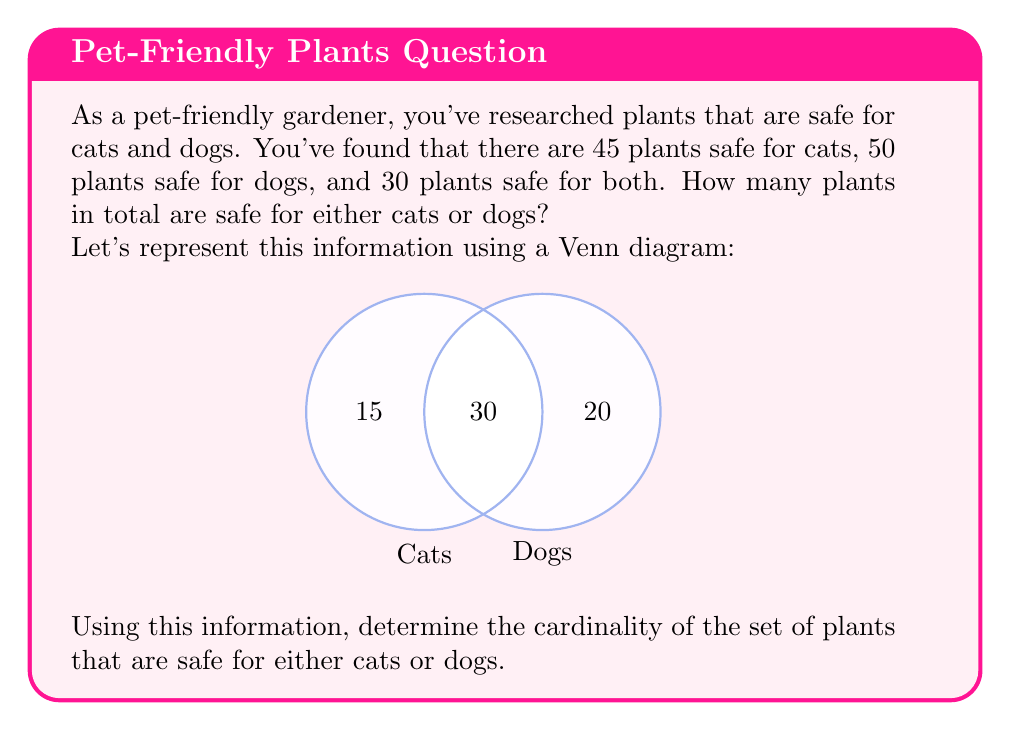Show me your answer to this math problem. Let's approach this step-by-step using set theory:

1) Let A be the set of plants safe for cats, and B be the set of plants safe for dogs.

2) We're given:
   $|A| = 45$ (plants safe for cats)
   $|B| = 50$ (plants safe for dogs)
   $|A \cap B| = 30$ (plants safe for both)

3) We need to find $|A \cup B|$, which represents the total number of plants safe for either cats or dogs.

4) We can use the inclusion-exclusion principle:
   $|A \cup B| = |A| + |B| - |A \cap B|$

5) Substituting the values:
   $|A \cup B| = 45 + 50 - 30$

6) Calculate:
   $|A \cup B| = 95 - 30 = 65$

Therefore, the cardinality of the set of plants that are safe for either cats or dogs is 65.
Answer: 65 